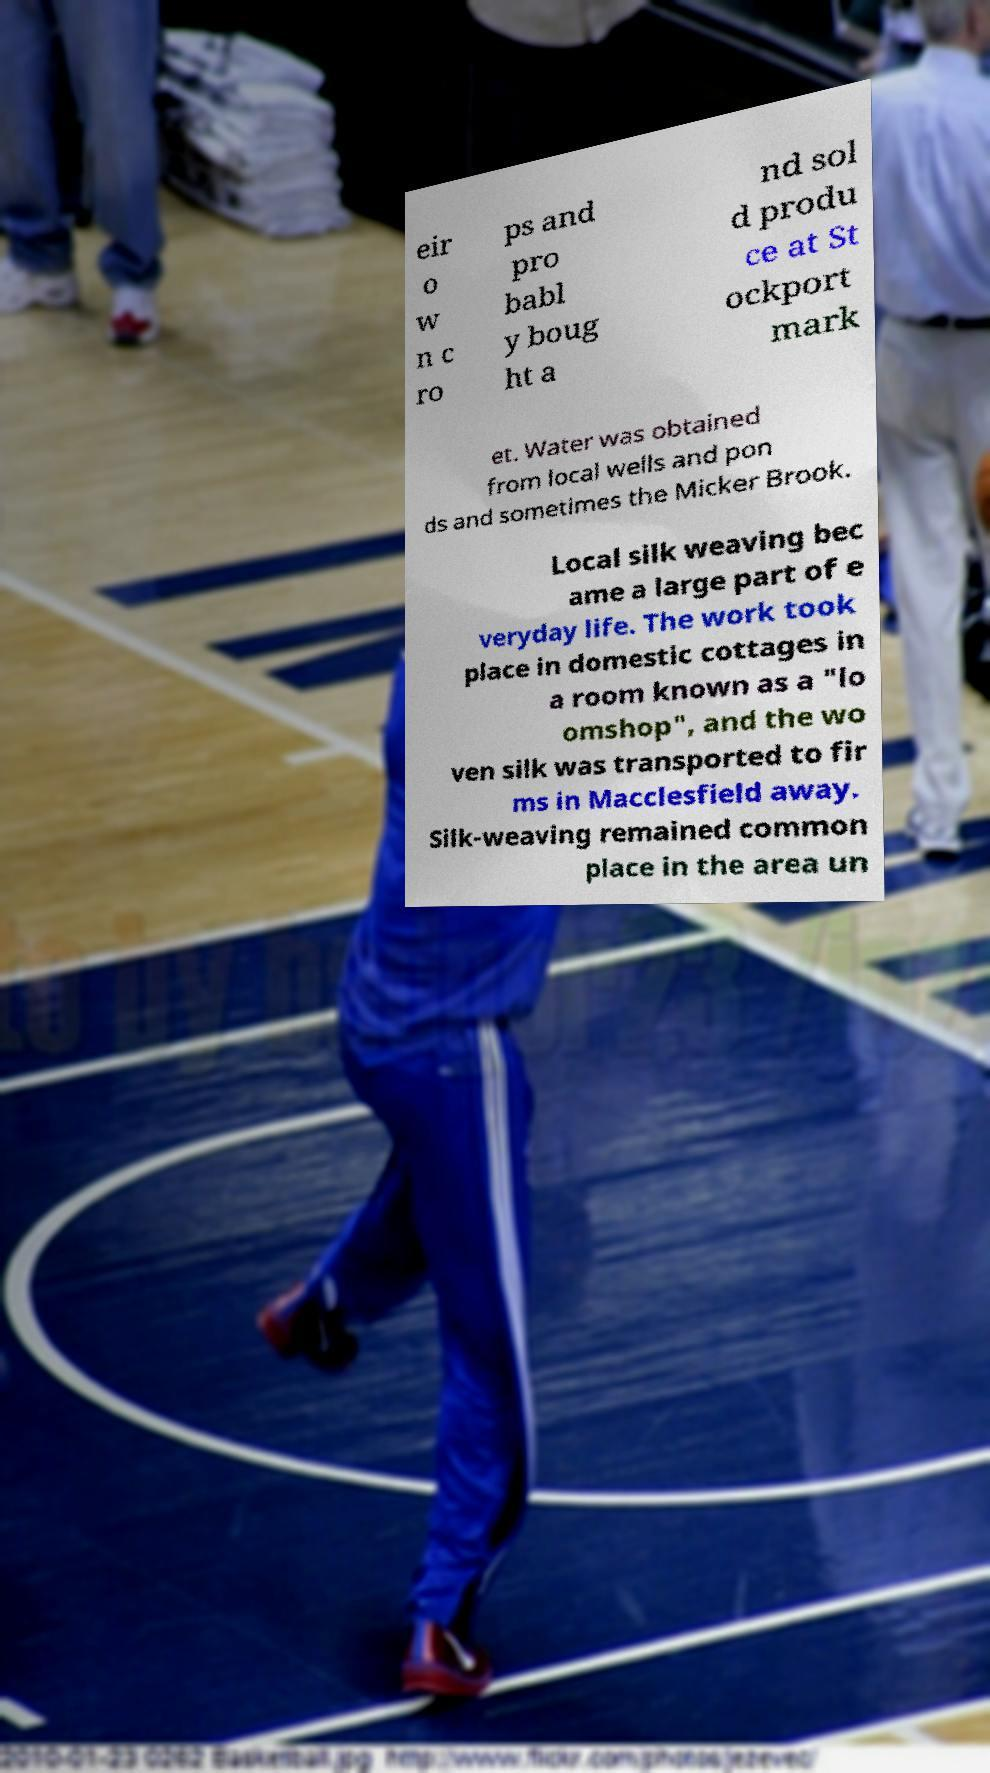Could you assist in decoding the text presented in this image and type it out clearly? eir o w n c ro ps and pro babl y boug ht a nd sol d produ ce at St ockport mark et. Water was obtained from local wells and pon ds and sometimes the Micker Brook. Local silk weaving bec ame a large part of e veryday life. The work took place in domestic cottages in a room known as a "lo omshop", and the wo ven silk was transported to fir ms in Macclesfield away. Silk-weaving remained common place in the area un 